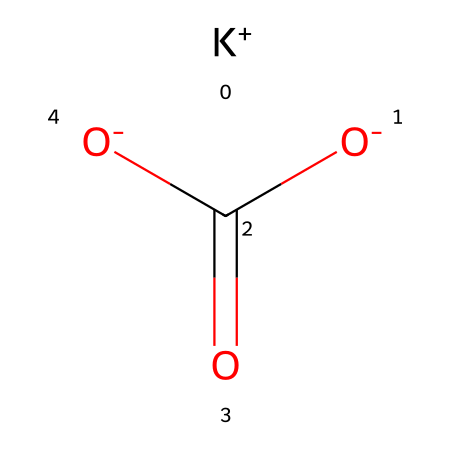What is the name of this chemical? The chemical represented by the SMILES notation is potassium bicarbonate, which is derived from its ionic components: potassium (K+) and bicarbonate (HCO3−).
Answer: potassium bicarbonate How many oxygen atoms are present in this molecule? Analyzing the structure, there are three oxygen atoms associated with the bicarbonate part of the molecule: two from the carbonic part and one additional oxygen that carries a negative charge (O-).
Answer: three What type of ion is represented by K+? The "K+" in the SMILES indicates that it is a positively charged ion, specifically a cation formed by the loss of one electron from potassium.
Answer: cation How many total atoms are in potassium bicarbonate? The molecule consists of 1 potassium atom, 1 carbon atom, 3 oxygen atoms, and 1 hydrogen atom, totaling 6 atoms when summed up.
Answer: six What functional group is present in this compound? The presence of the bicarbonate ion (HCO3−) indicates that this compound has a carboxylate functional group, as denoted by the -COO− structure.
Answer: carboxylate What is the charge of the bicarbonate ion in this molecule? The bicarbonate ion is represented as [O-]C(=O)[O-], indicating it has a total charge of -1 due to its chemical structure which includes two negatively charged oxygens and one neutral carbon.
Answer: negative one How does potassium bicarbonate function as an electrolyte? Potassium bicarbonate dissociates in solution to release K+ and HCO3− ions, allowing it to conduct electricity; this dissociation is typical of electrolytes.
Answer: conduct electricity 